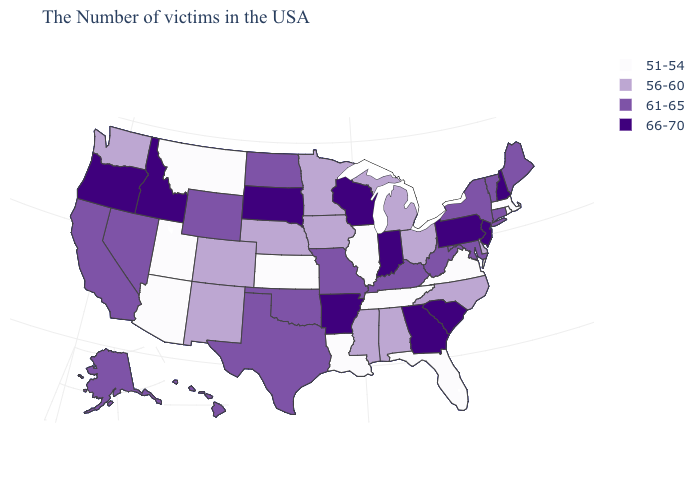What is the value of Alaska?
Answer briefly. 61-65. How many symbols are there in the legend?
Write a very short answer. 4. Name the states that have a value in the range 66-70?
Give a very brief answer. New Hampshire, New Jersey, Pennsylvania, South Carolina, Georgia, Indiana, Wisconsin, Arkansas, South Dakota, Idaho, Oregon. Name the states that have a value in the range 56-60?
Keep it brief. Delaware, North Carolina, Ohio, Michigan, Alabama, Mississippi, Minnesota, Iowa, Nebraska, Colorado, New Mexico, Washington. Does Illinois have the lowest value in the USA?
Keep it brief. Yes. What is the value of Maine?
Be succinct. 61-65. Does Utah have a higher value than Wyoming?
Give a very brief answer. No. What is the lowest value in states that border Washington?
Answer briefly. 66-70. What is the highest value in states that border Maryland?
Write a very short answer. 66-70. What is the value of Connecticut?
Keep it brief. 61-65. Does the map have missing data?
Short answer required. No. Which states have the lowest value in the USA?
Answer briefly. Massachusetts, Rhode Island, Virginia, Florida, Tennessee, Illinois, Louisiana, Kansas, Utah, Montana, Arizona. What is the value of Ohio?
Quick response, please. 56-60. Does New Hampshire have the highest value in the USA?
Keep it brief. Yes. Is the legend a continuous bar?
Write a very short answer. No. 